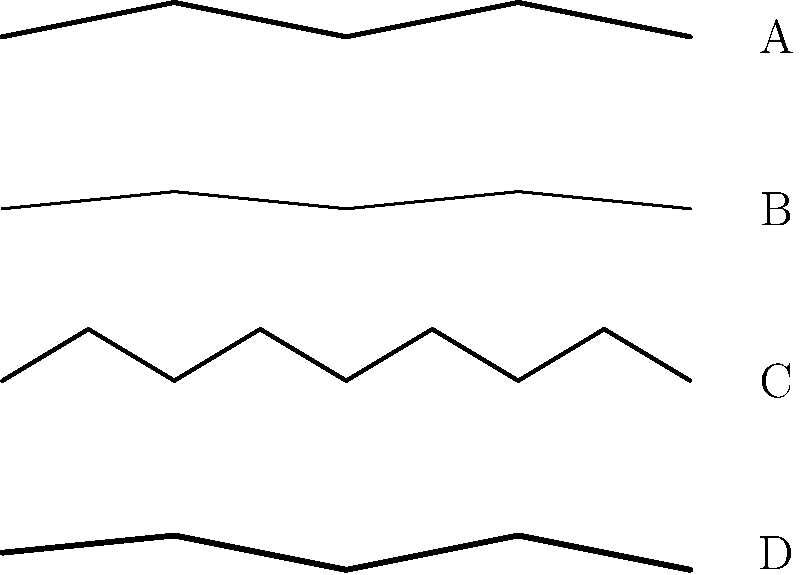Identify the fabric texture that would be most suitable for creating a luxurious, light-reflecting surface in a high-end living room rendering. To determine the most suitable fabric texture for a luxurious, light-reflecting surface in a high-end living room rendering, let's analyze each texture:

1. Texture A: This represents velvet. It has a dense, plush appearance with a slight pile, creating a rich and luxurious look. Velvet is known for its ability to reflect light in a unique way, creating a shimmering effect as light hits it from different angles.

2. Texture B: This represents silk. It has a very smooth, fine texture with a subtle sheen. Silk is highly reflective and known for its lustrous appearance, making it an excellent choice for luxurious settings.

3. Texture C: This represents linen. It has a more pronounced, irregular texture with visible fibers. While linen can be used in high-end settings, it's typically associated with a more casual, relaxed look and doesn't have the same light-reflecting properties as velvet or silk.

4. Texture D: This represents leather. It has a smooth but slightly irregular surface. While leather can be luxurious, it doesn't typically reflect light in the same way as fabrics like velvet or silk.

For creating a luxurious, light-reflecting surface in a high-end living room rendering, the most suitable texture would be either velvet (A) or silk (B). However, silk (B) is generally considered to have superior light-reflecting properties, creating a more lustrous and shimmering effect that would enhance the luxurious feel of a high-end living room rendering.
Answer: B (Silk) 